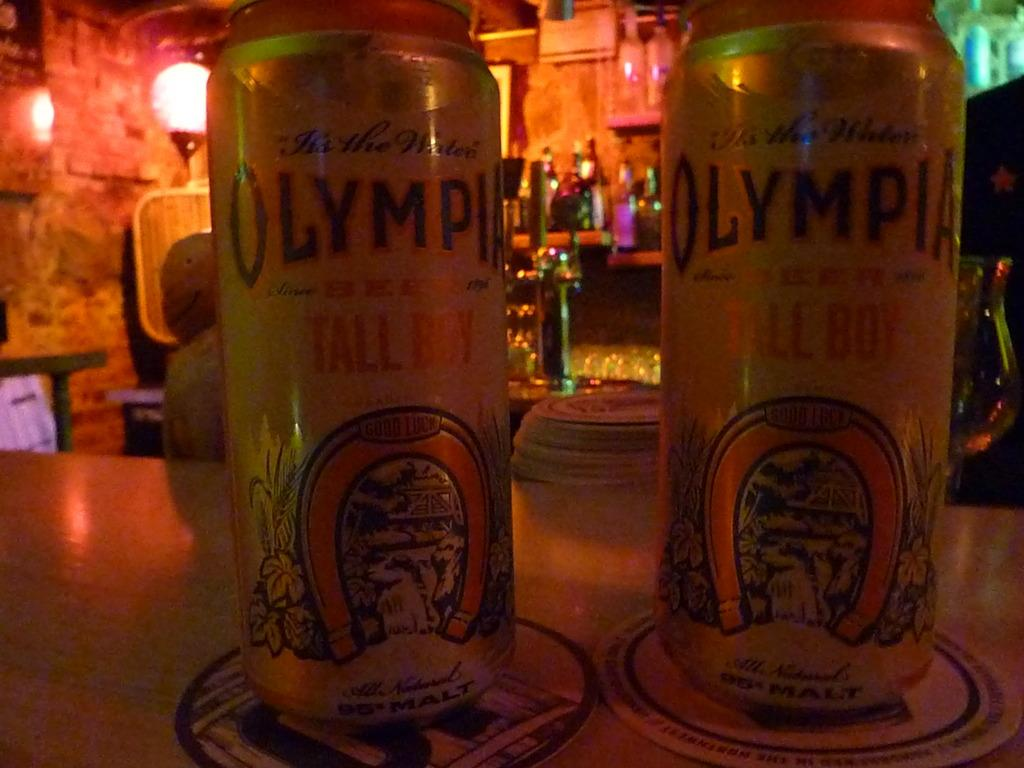<image>
Describe the image concisely. Two bottles of Olympia beer placed next to one another. 